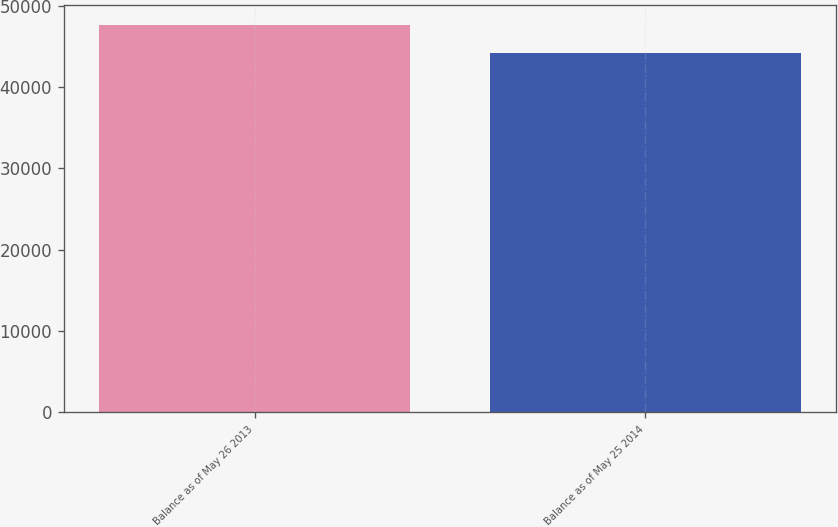Convert chart to OTSL. <chart><loc_0><loc_0><loc_500><loc_500><bar_chart><fcel>Balance as of May 26 2013<fcel>Balance as of May 25 2014<nl><fcel>47672.1<fcel>44169<nl></chart> 